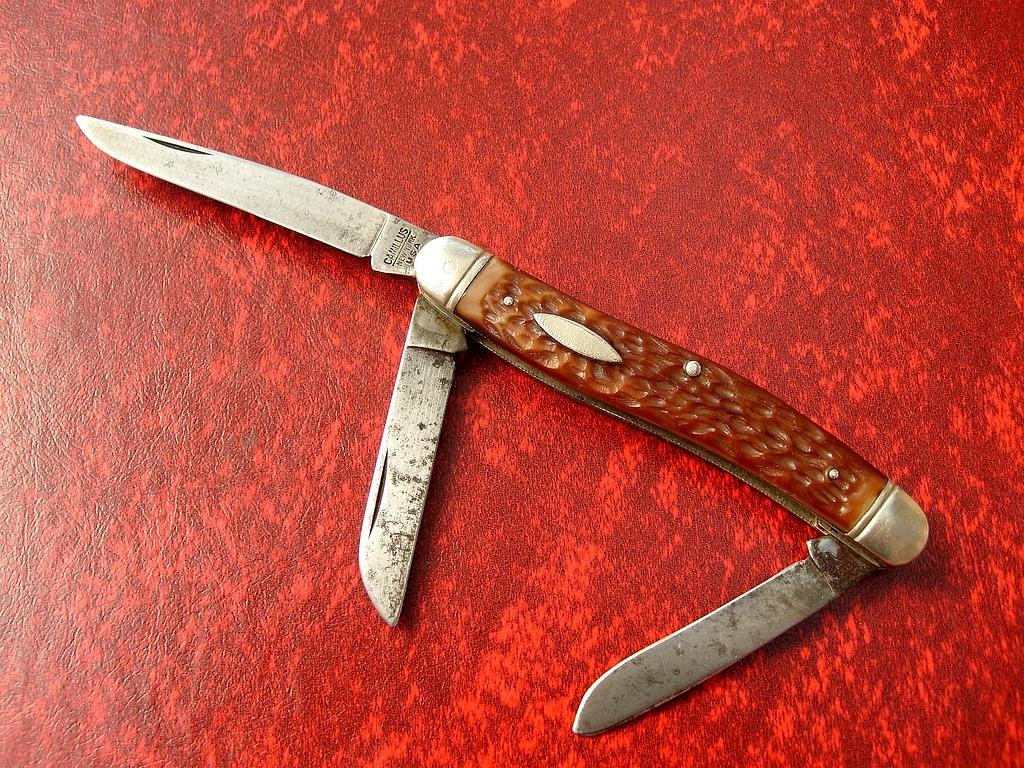How many plates are visible in the image? There are three plates in the foreground of the image. What is placed on the plates? There is a folding knife on the plates. What is the color of the surface beneath the plates? The surface beneath the plates is red in color. What type of balloon can be seen floating above the plates in the image? There is no balloon present in the image; it only features three plates and a folding knife. 